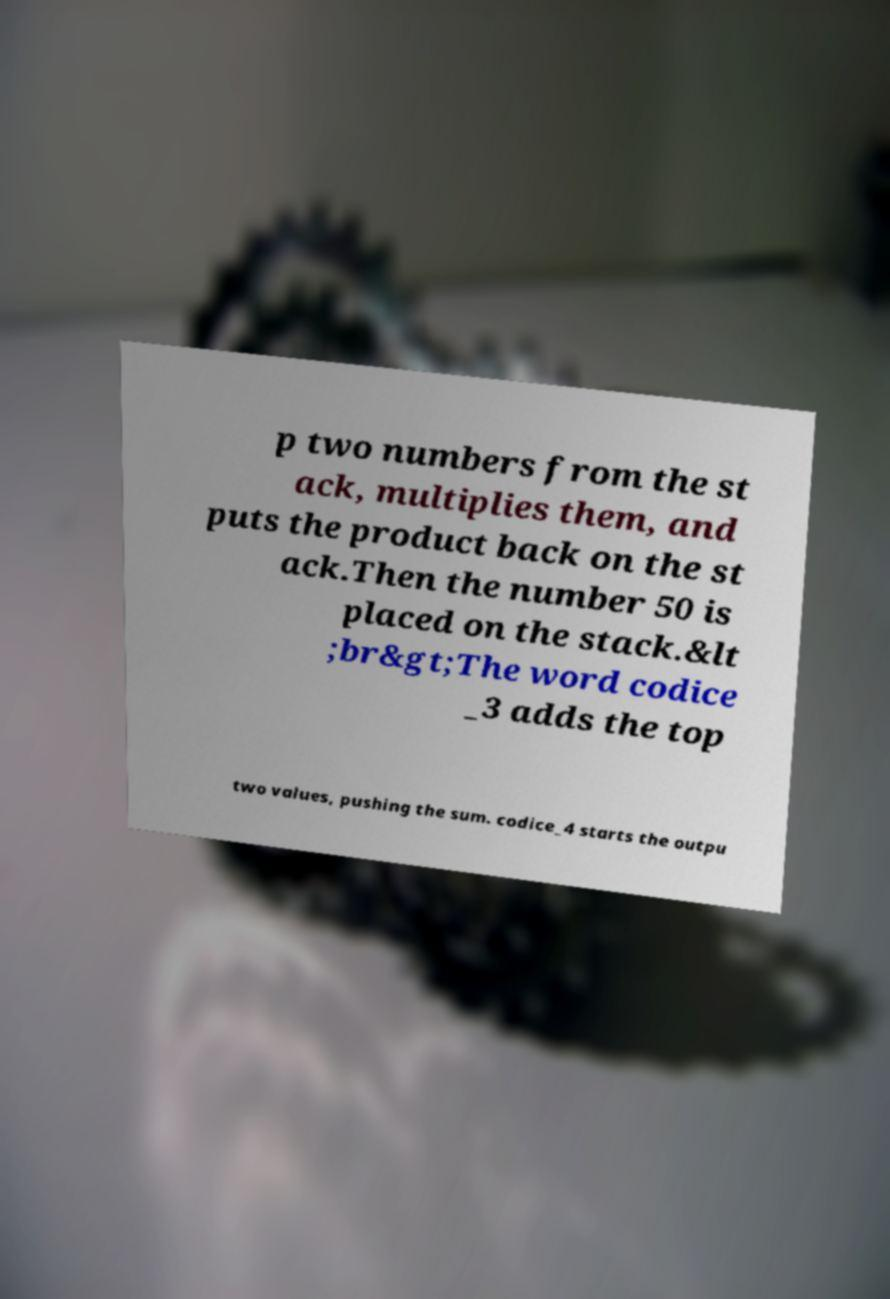For documentation purposes, I need the text within this image transcribed. Could you provide that? p two numbers from the st ack, multiplies them, and puts the product back on the st ack.Then the number 50 is placed on the stack.&lt ;br&gt;The word codice _3 adds the top two values, pushing the sum. codice_4 starts the outpu 